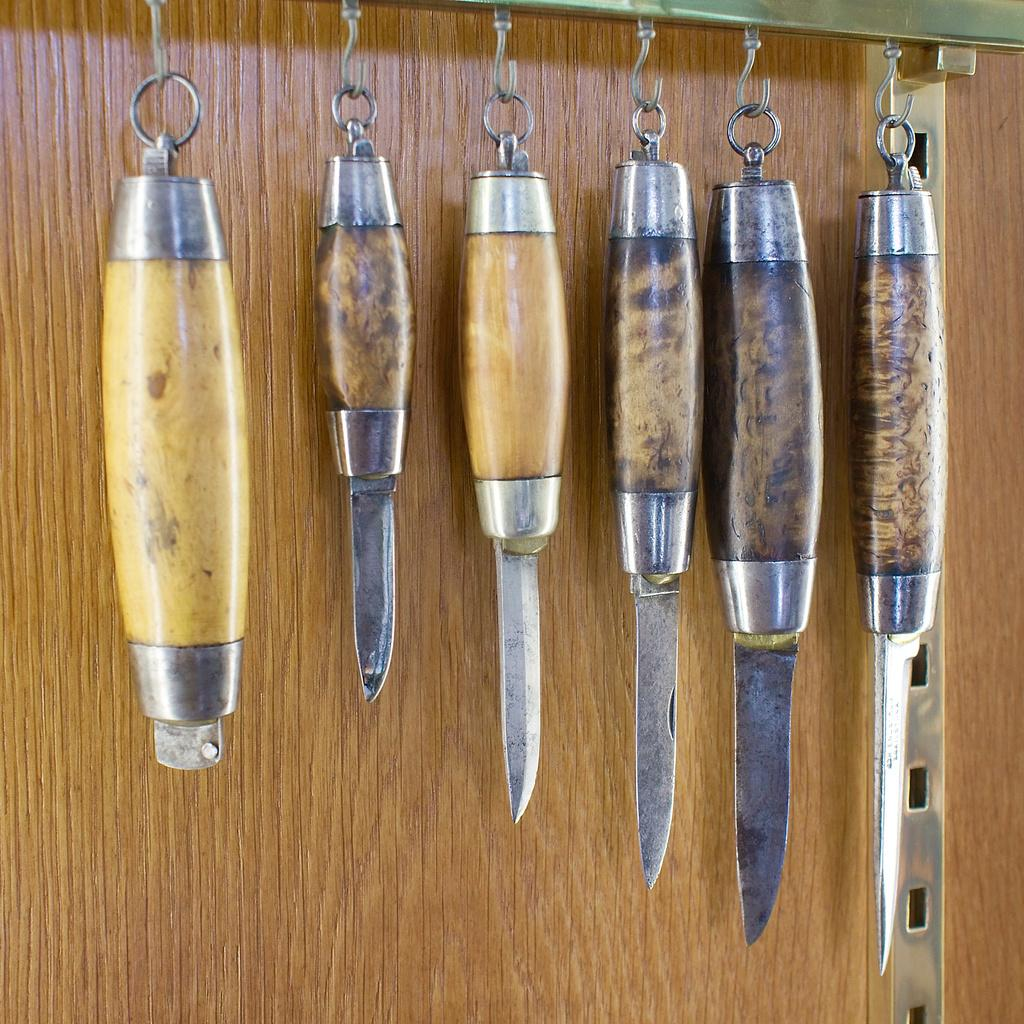What objects are present in the image? There are different types of knives in the image. How are the knives arranged in the image? The knives are hanging on hooks. What type of surface can be seen in the image? There is a wooden surface in the image. What shape is the smoke forming in the image? There is no smoke present in the image. 